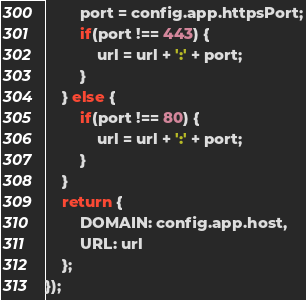Convert code to text. <code><loc_0><loc_0><loc_500><loc_500><_JavaScript_>		port = config.app.httpsPort;
		if(port !== 443) {
			url = url + ':' + port;
		}
	} else {
		if(port !== 80) {
			url = url + ':' + port;
		}
	}
	return {
		DOMAIN: config.app.host,
		URL: url
	};
});</code> 